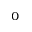Convert formula to latex. <formula><loc_0><loc_0><loc_500><loc_500>^ { 0 }</formula> 